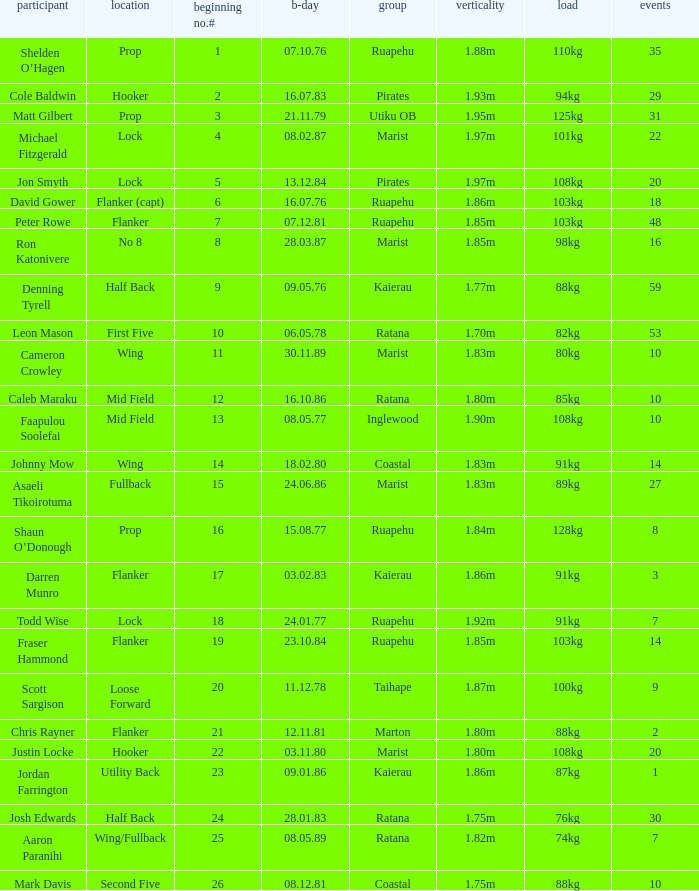What is the date of birth for the player in the Inglewood club? 80577.0. 